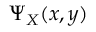Convert formula to latex. <formula><loc_0><loc_0><loc_500><loc_500>\Psi _ { X } ( x , y )</formula> 